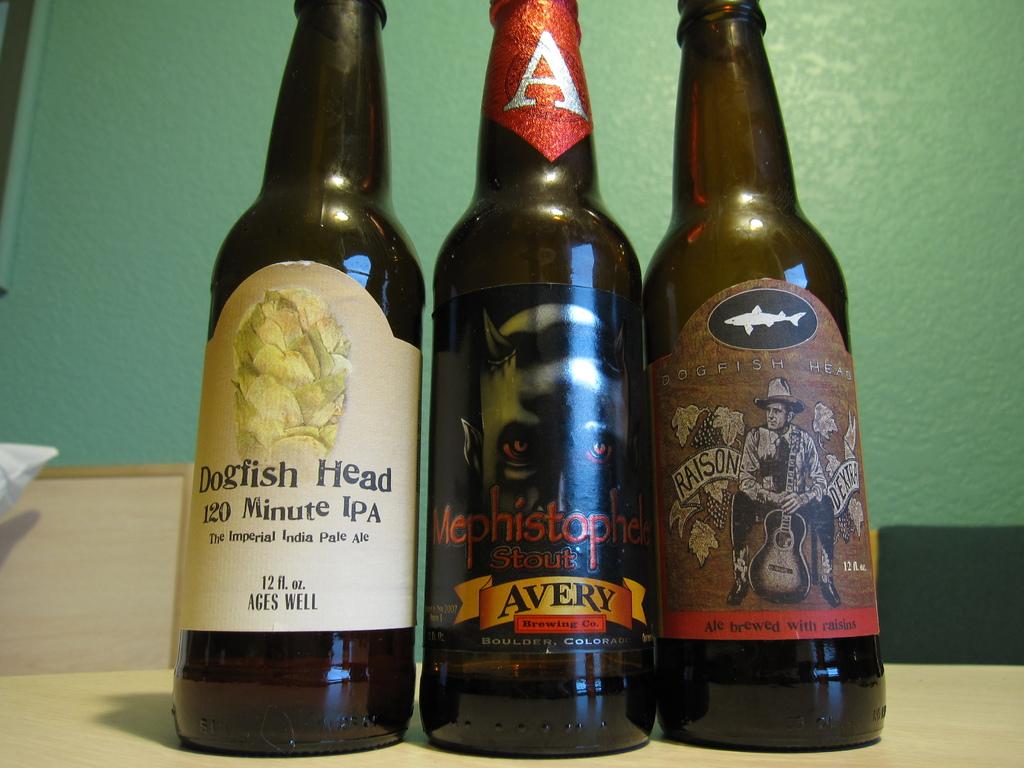What is the volume of the bottle?
Give a very brief answer. 12 fl oz. What brand is on the left?
Provide a short and direct response. Dogfish head. 